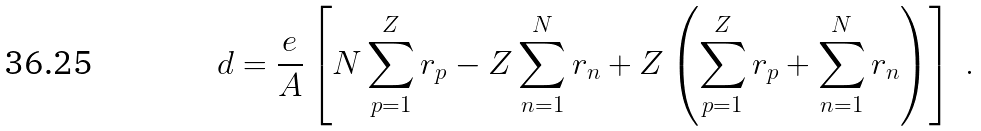<formula> <loc_0><loc_0><loc_500><loc_500>d = \frac { e } { A } \left [ N \sum _ { p = 1 } ^ { Z } r _ { p } - Z \sum _ { n = 1 } ^ { N } r _ { n } + Z \left ( \sum _ { p = 1 } ^ { Z } r _ { p } + \sum _ { n = 1 } ^ { N } r _ { n } \right ) \right ] \ .</formula> 